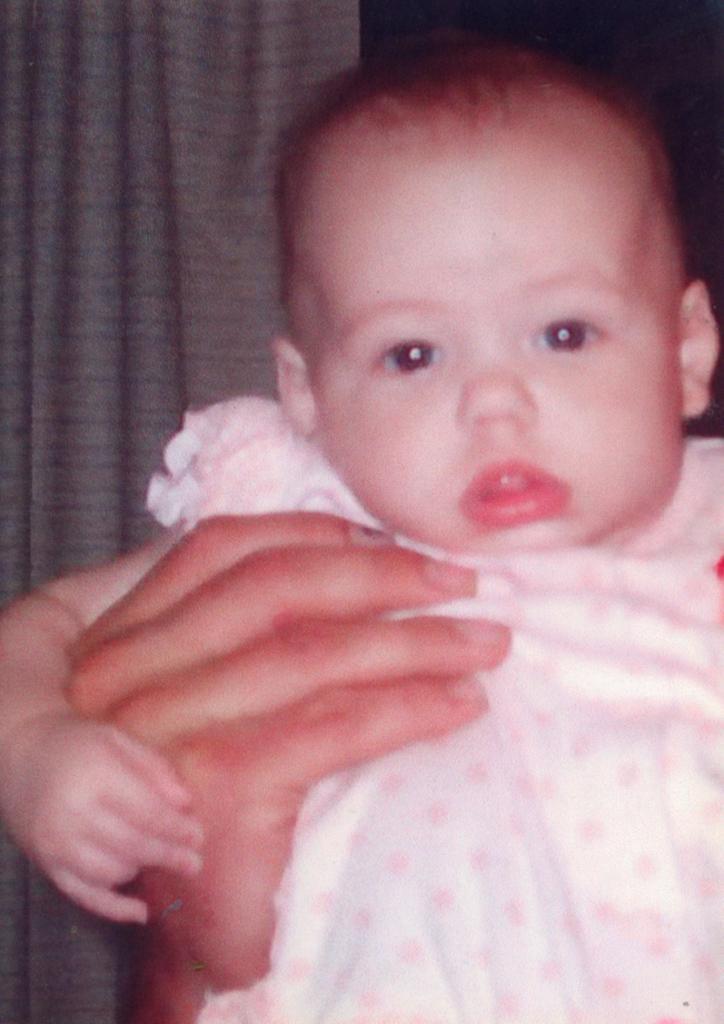Please provide a concise description of this image. This image consists of a small kid. The person is holding the kid. In the background, there is a curtain in gray color. The kid is wearing white and pink dress. 